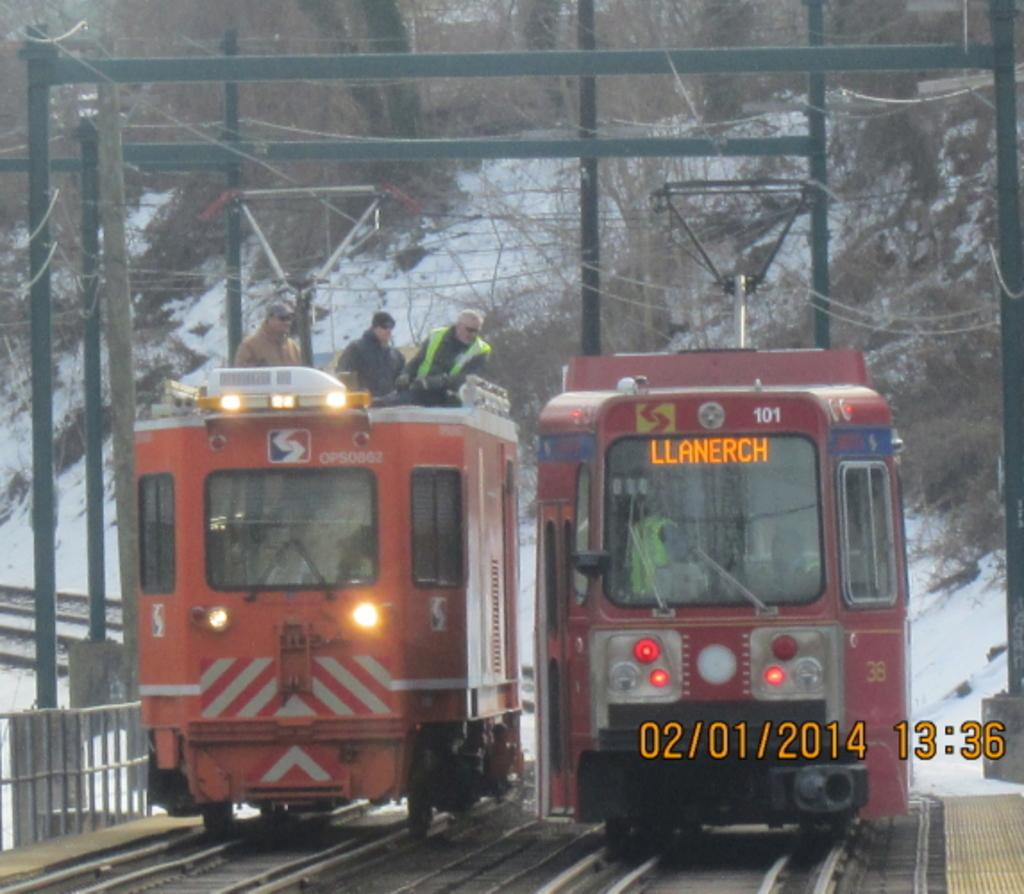<image>
Summarize the visual content of the image. the date of February is on the bottom right next to the trains 